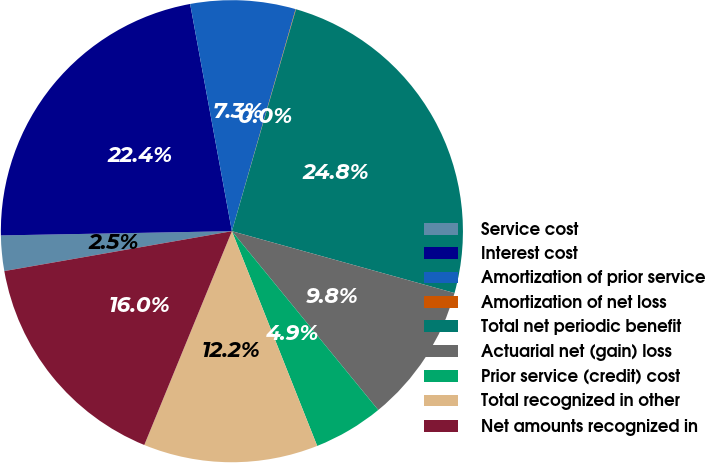<chart> <loc_0><loc_0><loc_500><loc_500><pie_chart><fcel>Service cost<fcel>Interest cost<fcel>Amortization of prior service<fcel>Amortization of net loss<fcel>Total net periodic benefit<fcel>Actuarial net (gain) loss<fcel>Prior service (credit) cost<fcel>Total recognized in other<fcel>Net amounts recognized in<nl><fcel>2.47%<fcel>22.4%<fcel>7.34%<fcel>0.03%<fcel>24.84%<fcel>9.77%<fcel>4.9%<fcel>12.21%<fcel>16.05%<nl></chart> 